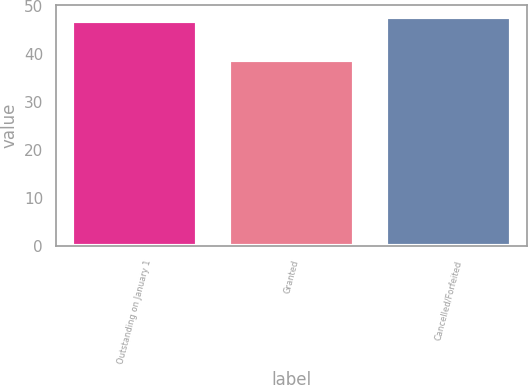<chart> <loc_0><loc_0><loc_500><loc_500><bar_chart><fcel>Outstanding on January 1<fcel>Granted<fcel>Cancelled/Forfeited<nl><fcel>46.78<fcel>38.71<fcel>47.67<nl></chart> 